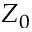<formula> <loc_0><loc_0><loc_500><loc_500>Z _ { 0 }</formula> 